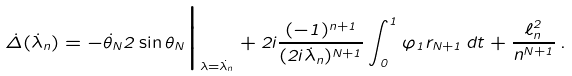<formula> <loc_0><loc_0><loc_500><loc_500>\dot { \Delta } ( \dot { \lambda } _ { n } ) = - \dot { \theta } _ { N } 2 \sin \theta _ { N } \Big | _ { \lambda = \dot { \lambda } _ { n } } + 2 i \frac { ( - 1 ) ^ { n + 1 } } { ( 2 i \dot { \lambda } _ { n } ) ^ { N + 1 } } \int _ { 0 } ^ { 1 } \varphi _ { 1 } r _ { N + 1 } \, d t + \frac { \ell ^ { 2 } _ { n } } { n ^ { N + 1 } } \, .</formula> 